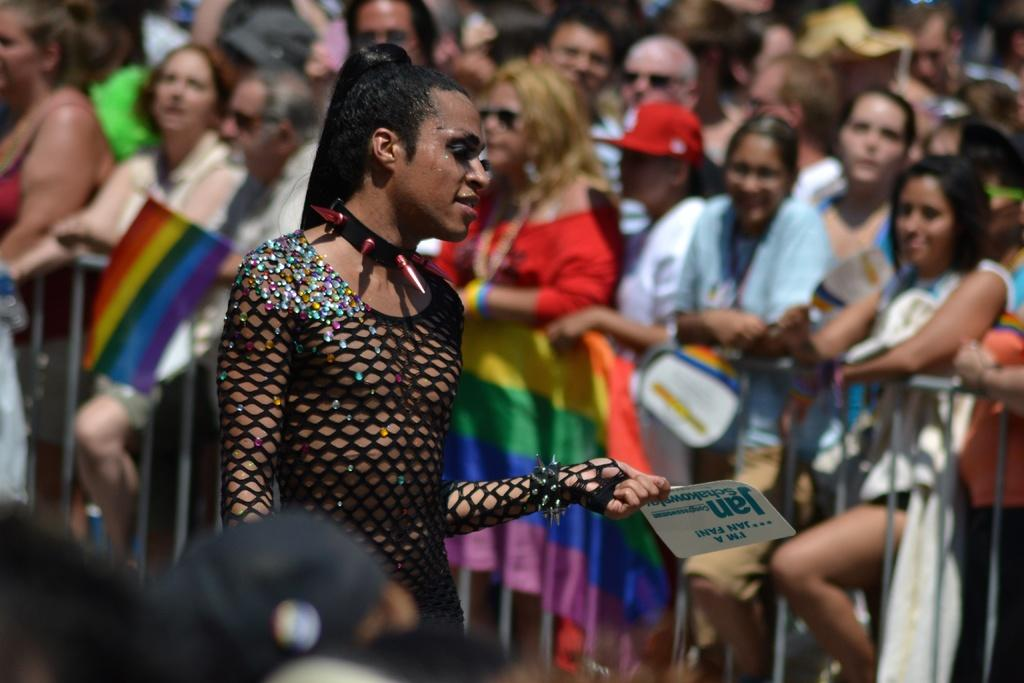What is the person in the foreground of the image doing? The person is standing and holding a board. Can you describe the people in the background of the image? There are people in the background of the image, but their specific actions or appearances are not mentioned in the facts. What can be seen in the background of the image besides people? There is a fence and flags in the background of the image. What type of sack is being carried by the visitor in the image? There is no visitor or sack present in the image. How does the person holding the board move in the image? The person holding the board is not shown in motion in the image; they are standing still. 